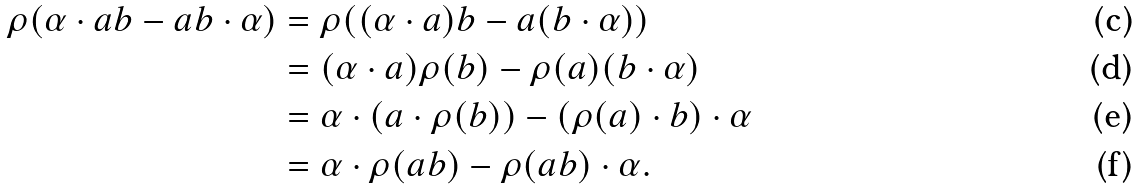<formula> <loc_0><loc_0><loc_500><loc_500>\rho ( \alpha \cdot a b - a b \cdot \alpha ) & = \rho ( ( \alpha \cdot a ) b - a ( b \cdot \alpha ) ) \\ & = ( \alpha \cdot a ) \rho ( b ) - \rho ( a ) ( b \cdot \alpha ) \\ & = \alpha \cdot ( a \cdot \rho ( b ) ) - ( \rho ( a ) \cdot b ) \cdot \alpha \\ & = \alpha \cdot \rho ( a b ) - \rho ( a b ) \cdot \alpha .</formula> 